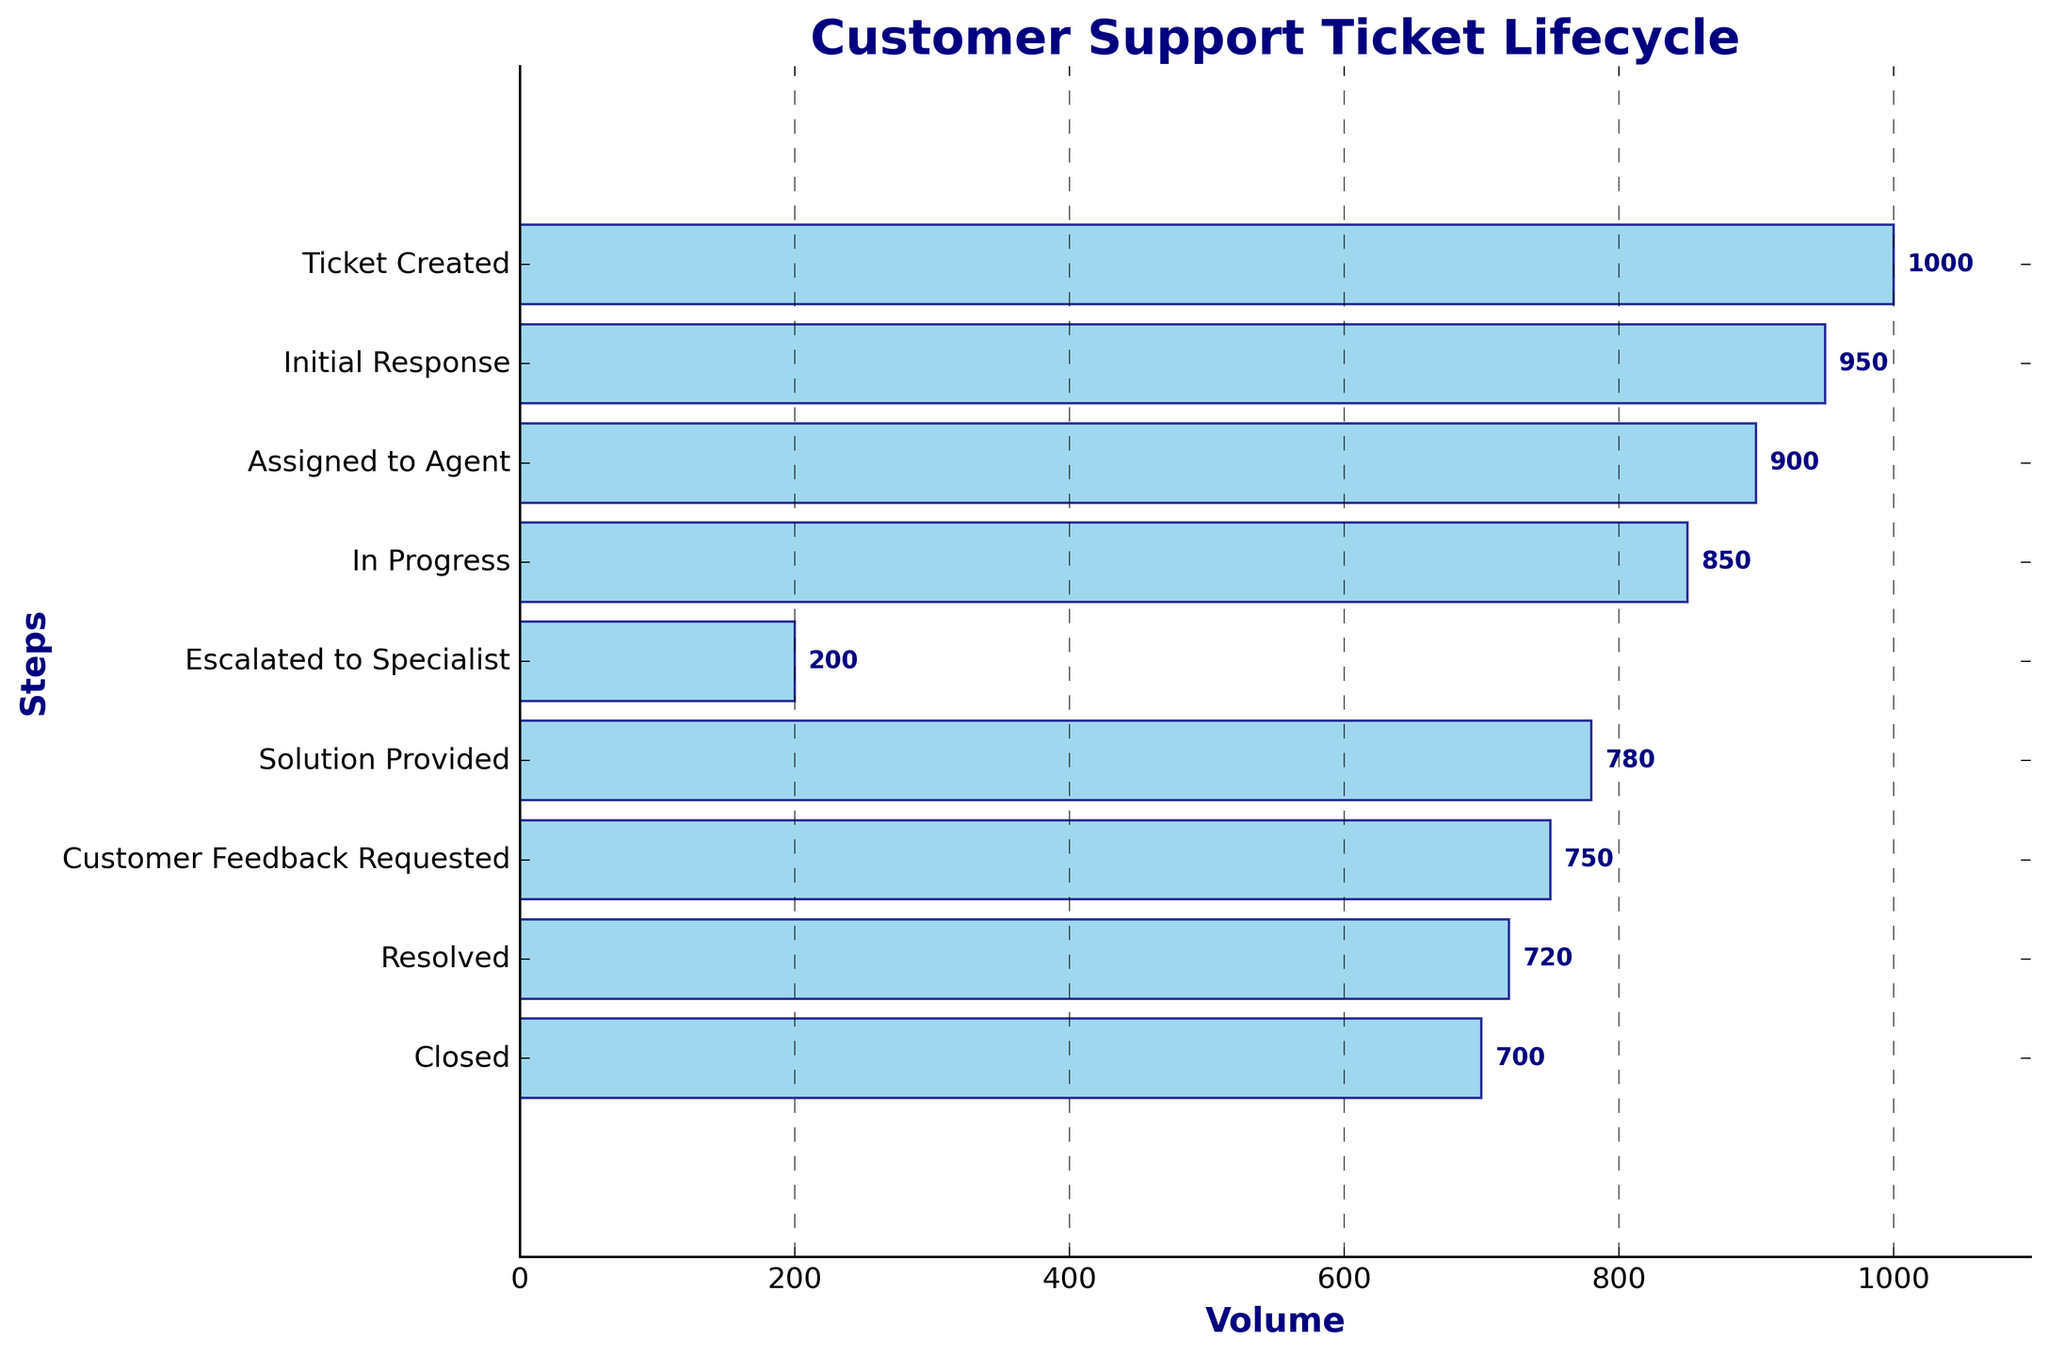Which step has the highest volume of tickets? By looking at the figure, the step with the longest bar represents the highest volume, which corresponds to "Ticket Created" with a volume of 1000.
Answer: Ticket Created What is the title of the chart? The title is located at the top of the figure and it reads "Customer Support Ticket Lifecycle."
Answer: Customer Support Ticket Lifecycle How many steps are displayed in the funnel chart? Count each distinct label along the y-axis of the chart to find the number of steps. There are 9 steps.
Answer: 9 What is the difference in the volume of tickets between "In Progress" and "Escalated to Specialist"? The volume of "In Progress" is 850, and for "Escalated to Specialist," it's 200. Subtracting these gives 850 - 200.
Answer: 650 Which step shows the highest drop in ticket volume? Compare the volumes between successive steps. The biggest drop is from "In Progress" (850) to "Escalated to Specialist" (200), which is 650 tickets.
Answer: In Progress to Escalated to Specialist Are there any steps where the volume does not change significantly compared to the previous step? Yes, compare successive steps for minimal differences. The step "Customer Feedback Requested" (750) is quite close to "Resolved" (720), a difference of just 30 tickets.
Answer: Customer Feedback Requested to Resolved What volume of tickets is present at the final step and what is the step name? The final step is at the bottom of the chart and shows "Closed" with 700 tickets.
Answer: Closed, 700 What is the average ticket volume across all the steps? Sum the volumes and divide by the number of steps: (1000 + 950 + 900 + 850 + 200 + 780 + 750 + 720 + 700) / 9 = 650
Answer: 650 What is the relation between "Assigned to Agent" and "Solution Provided" in terms of volume? Compare the volumes: "Assigned to Agent" has 900 tickets and "Solution Provided" has 780. "Assigned to Agent" has a higher volume than "Solution Provided."
Answer: Assigned to Agent > Solution Provided Which step directly follows "Initial Response" in the ticket lifecycle? The step after "Initial Response" in the list (order) is "Assigned to Agent."
Answer: Assigned to Agent 